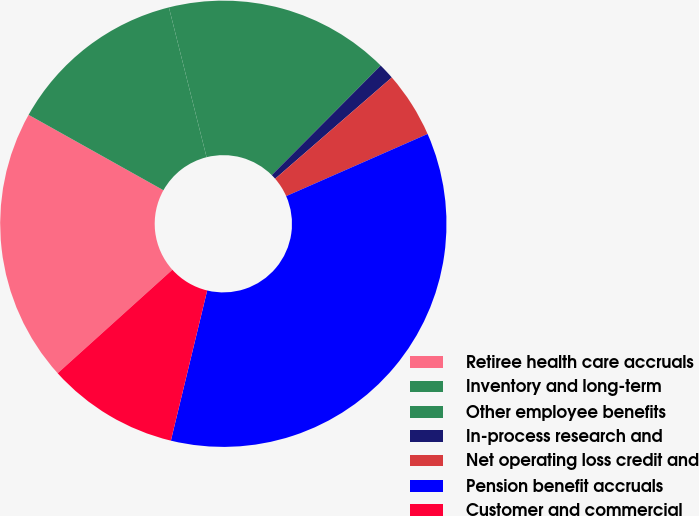Convert chart to OTSL. <chart><loc_0><loc_0><loc_500><loc_500><pie_chart><fcel>Retiree health care accruals<fcel>Inventory and long-term<fcel>Other employee benefits<fcel>In-process research and<fcel>Net operating loss credit and<fcel>Pension benefit accruals<fcel>Customer and commercial<nl><fcel>19.8%<fcel>12.96%<fcel>16.38%<fcel>1.16%<fcel>4.79%<fcel>35.37%<fcel>9.54%<nl></chart> 